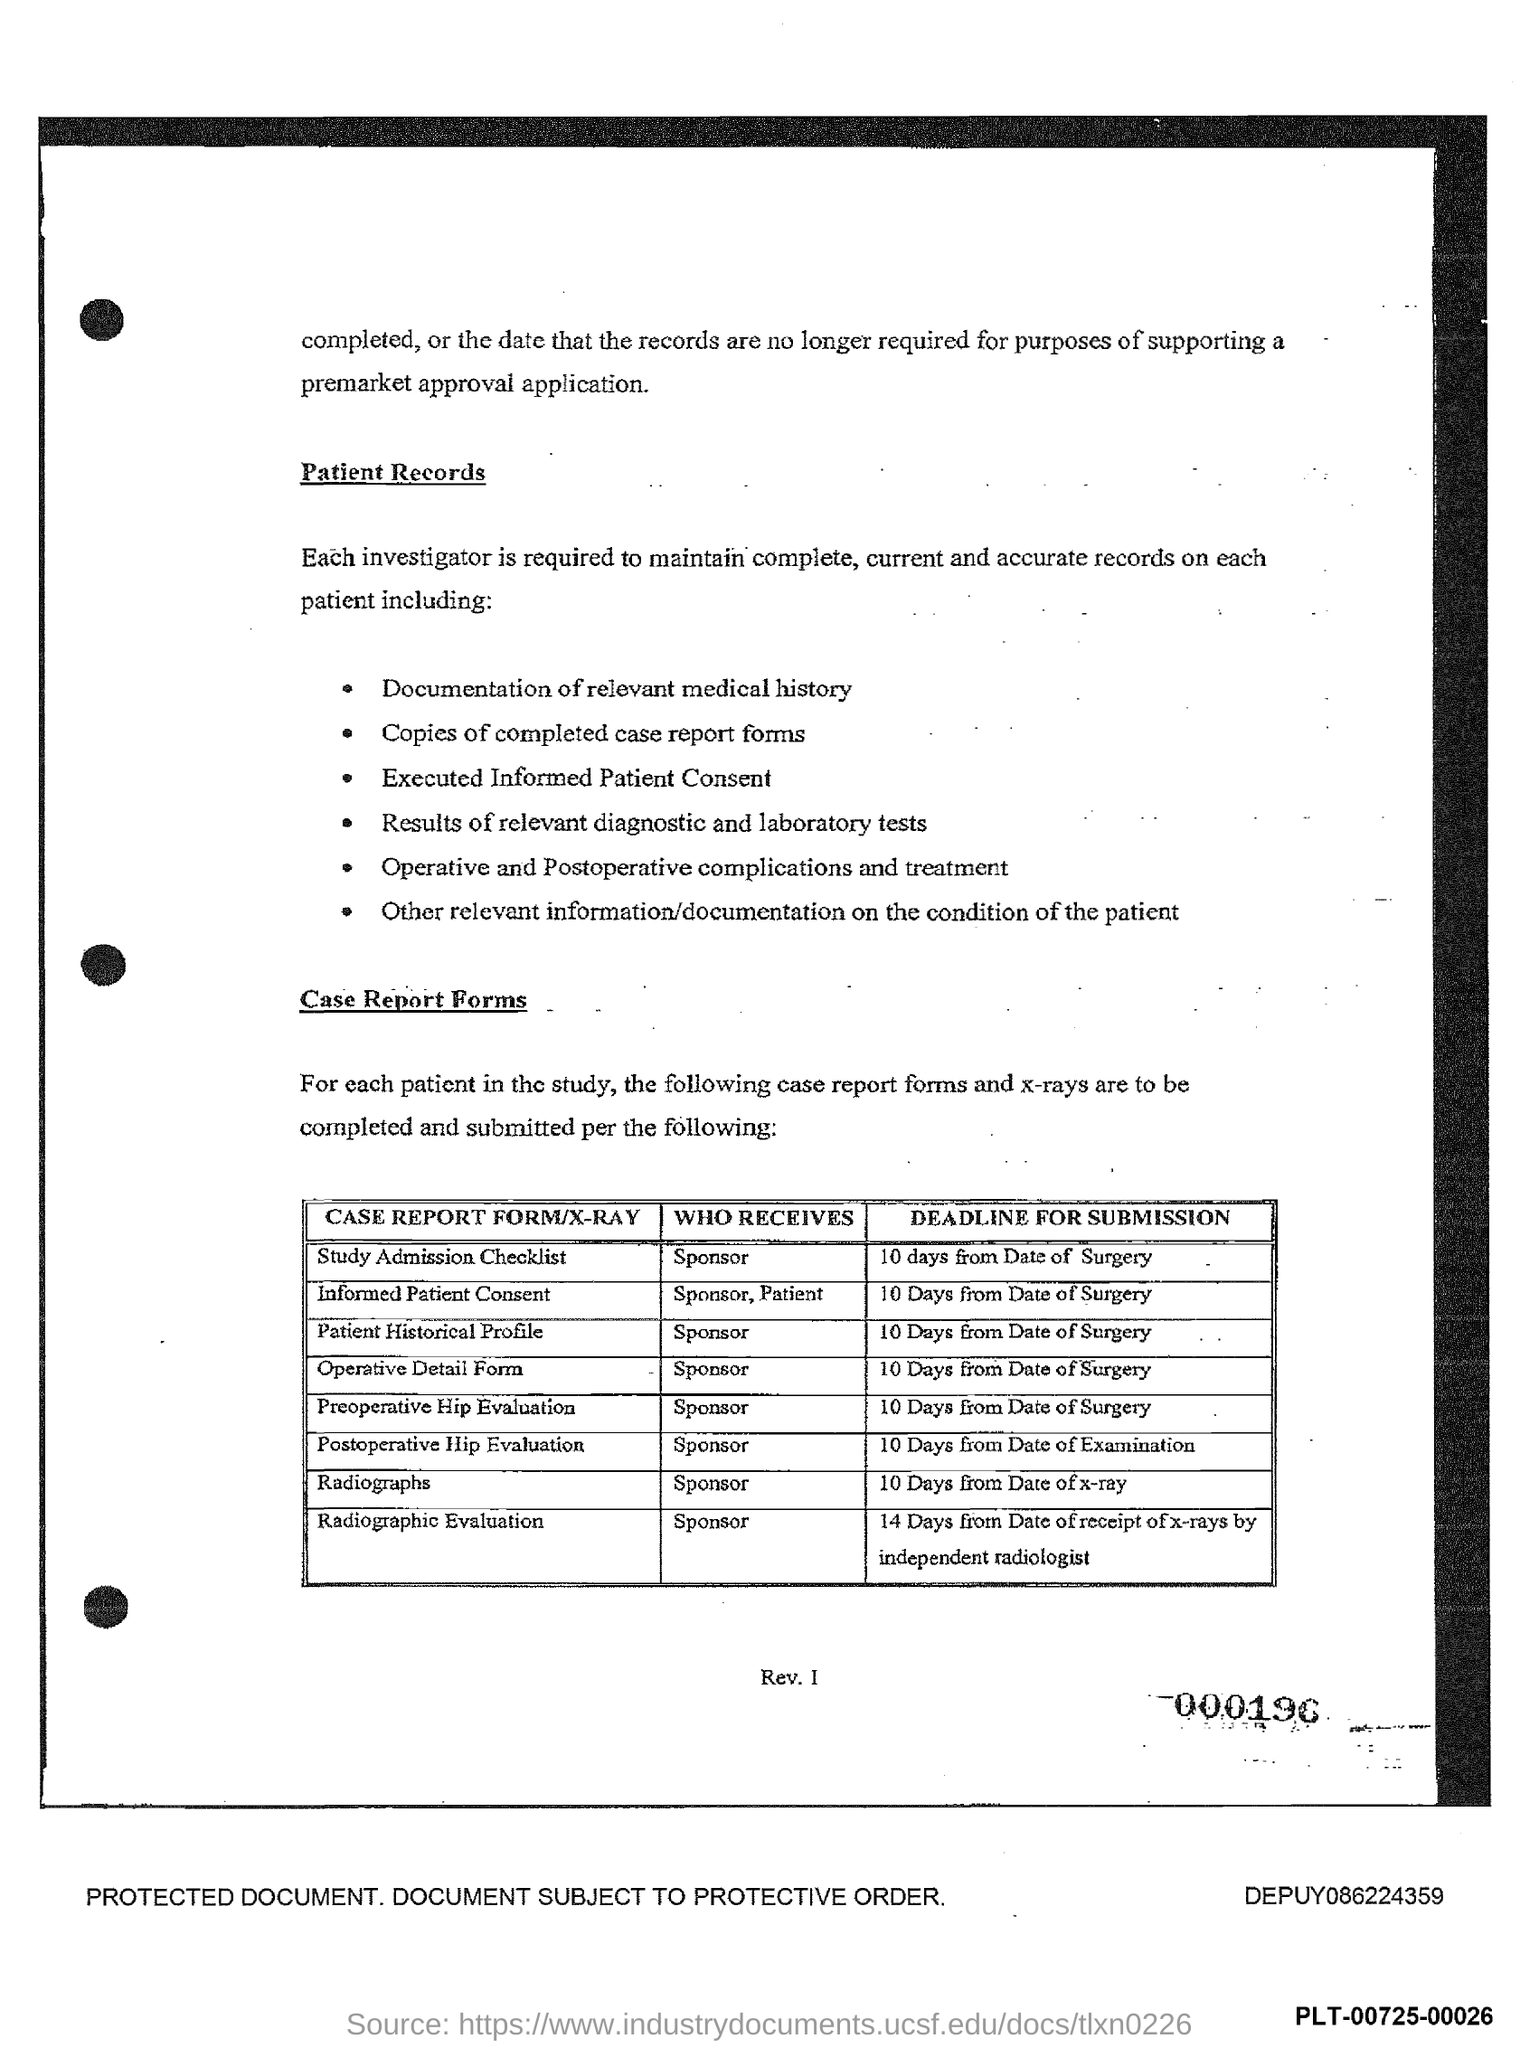Mention a couple of crucial points in this snapshot. The Informed Patient Consent form must be submitted ten days after the date of the surgical procedure. The Operative Detail form is provided to the sponsor as specified in the document. The deadline for the submission of radiographs is ten days from the date of the x-ray examination. The Postoperative Hip Evaluation form must be submitted within 10 days from the date of examination. The document indicates that the study admission checklist should be provided to the sponsor. 